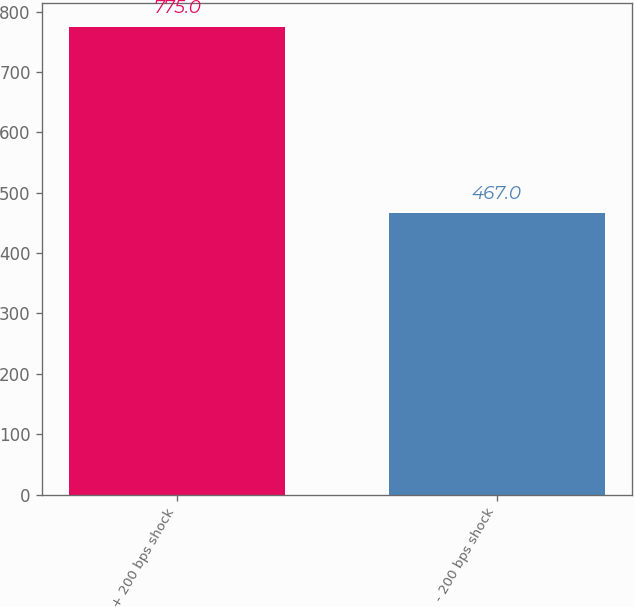<chart> <loc_0><loc_0><loc_500><loc_500><bar_chart><fcel>+ 200 bps shock<fcel>- 200 bps shock<nl><fcel>775<fcel>467<nl></chart> 